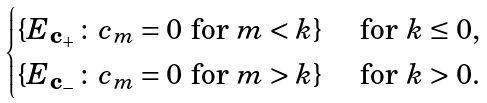<formula> <loc_0><loc_0><loc_500><loc_500>\begin{cases} \{ E _ { \mathbf c _ { + } } \colon c _ { m } = 0 \text { for } m < k \} & \text { for } k \leq 0 , \\ \{ E _ { \mathbf c _ { - } } \colon c _ { m } = 0 \text { for } m > k \} & \text { for } k > 0 . \end{cases}</formula> 